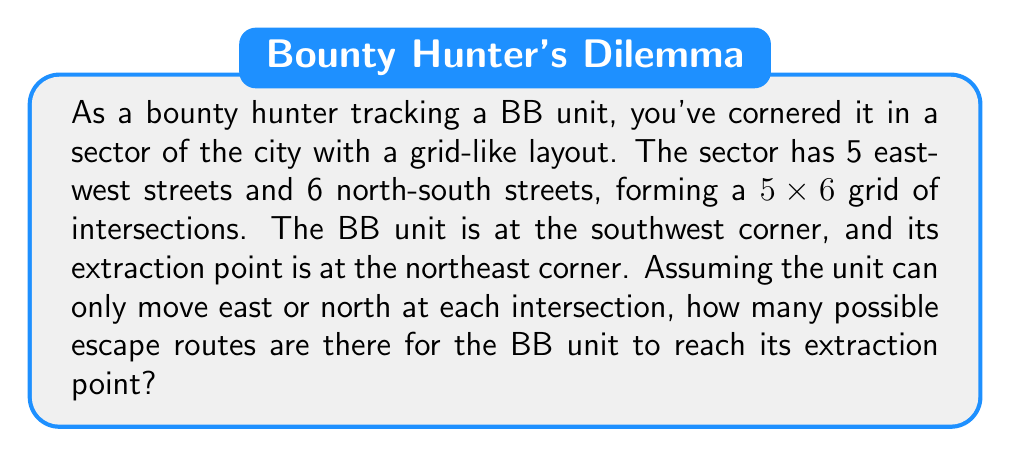Can you solve this math problem? To solve this problem, we can use the concept of lattice paths in combinatorics. Here's a step-by-step explanation:

1) First, let's visualize the grid:

[asy]
unitsize(1cm);
for(int i=0; i<=5; ++i) draw((0,i)--(6,i));
for(int j=0; j<=6; ++j) draw((j,0)--(j,5));
label("Start", (0,0), SW);
label("End", (6,5), NE);
[/asy]

2) To reach the extraction point, the BB unit must move:
   - 6 steps east (to cover 6 blocks from west to east)
   - 5 steps north (to cover 5 blocks from south to north)

3) The total number of steps is always 11 (6 + 5), regardless of the route.

4) This scenario is equivalent to choosing which 6 out of the 11 total steps will be eastward moves (or equivalently, which 5 will be northward moves).

5) This is a combination problem. We can calculate it using the formula:

   $$\binom{11}{6} = \binom{11}{5} = \frac{11!}{6!(11-6)!} = \frac{11!}{6!5!}$$

6) Expanding this:
   $$\frac{11 \times 10 \times 9 \times 8 \times 7 \times 6!}{6! \times 5 \times 4 \times 3 \times 2 \times 1}$$

7) The 6! cancels out in the numerator and denominator:
   $$\frac{11 \times 10 \times 9 \times 8 \times 7}{5 \times 4 \times 3 \times 2 \times 1} = 462$$

Therefore, there are 462 possible escape routes for the BB unit.
Answer: 462 possible escape routes 